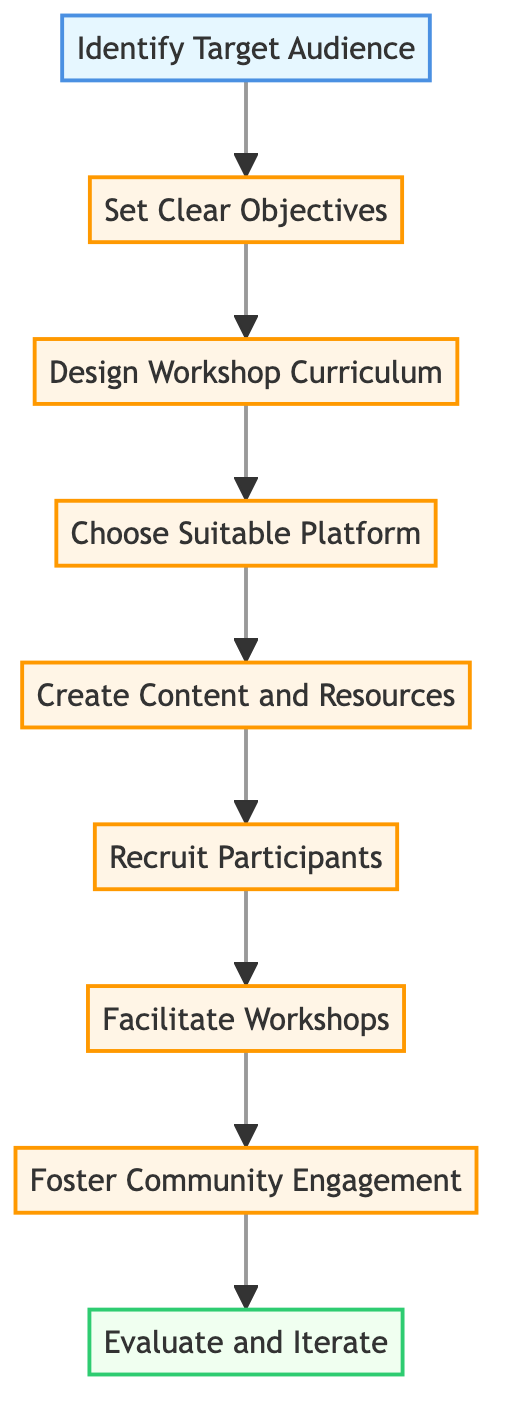What is the first step in the process? The first step is indicated at the bottom of the diagram, which states "Identify Target Audience." This element is connected to the next step in the flow.
Answer: Identify Target Audience How many steps are there before evaluating? To find this, count the number of steps from "Identify Target Audience" to "Evaluate and Iterate." There are 7 steps in total.
Answer: 7 What is the last step of the diagram? The last step is represented at the top of the flowchart, which is "Evaluate and Iterate." It synthesizes the previous steps and serves as a feedback loop.
Answer: Evaluate and Iterate Which step comes after "Recruit Participants"? In the flow of the diagram, the step that follows "Recruit Participants" is "Facilitate Workshops." This represents the next phase of engaging with the participants.
Answer: Facilitate Workshops What is one of the key objectives in designing the workshop? A key objective is located in the step "Design Workshop Curriculum," which involves creating a structured outline, emphasizing the importance of organization in workshops.
Answer: Create a structured outline What happens after fostering community engagement? Following "Foster Community Engagement," the next and final step is "Evaluate and Iterate." This signifies the importance of assessment after community building.
Answer: Evaluate and Iterate What action is necessary before creating content and resources? Before "Create Content and Resources," participants must be "Chosen Suitable Platform," which signifies the need to select a proper base for the workshop's delivery.
Answer: Choose Suitable Platform What is needed to encourage participant interaction? "Foster Community Engagement" focuses on encouraging networking and feedback, which are crucial elements in maintaining an active community.
Answer: Encourage networking and feedback How can one improve future workshops? Future workshops can be improved through feedback collected in the "Evaluate and Iterate" steps, indicating that participant input is essential for growth.
Answer: Gather feedback from participants 